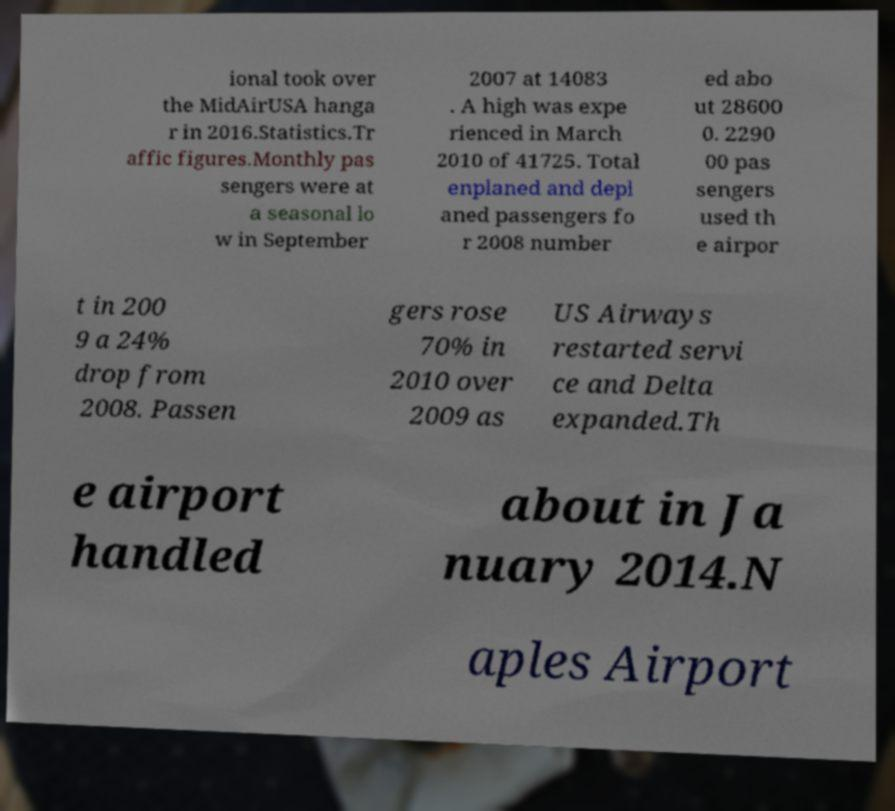Can you accurately transcribe the text from the provided image for me? ional took over the MidAirUSA hanga r in 2016.Statistics.Tr affic figures.Monthly pas sengers were at a seasonal lo w in September 2007 at 14083 . A high was expe rienced in March 2010 of 41725. Total enplaned and depl aned passengers fo r 2008 number ed abo ut 28600 0. 2290 00 pas sengers used th e airpor t in 200 9 a 24% drop from 2008. Passen gers rose 70% in 2010 over 2009 as US Airways restarted servi ce and Delta expanded.Th e airport handled about in Ja nuary 2014.N aples Airport 